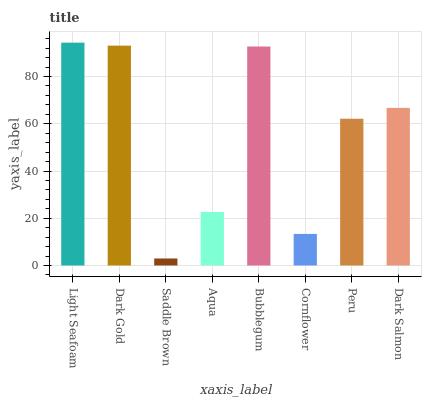Is Saddle Brown the minimum?
Answer yes or no. Yes. Is Light Seafoam the maximum?
Answer yes or no. Yes. Is Dark Gold the minimum?
Answer yes or no. No. Is Dark Gold the maximum?
Answer yes or no. No. Is Light Seafoam greater than Dark Gold?
Answer yes or no. Yes. Is Dark Gold less than Light Seafoam?
Answer yes or no. Yes. Is Dark Gold greater than Light Seafoam?
Answer yes or no. No. Is Light Seafoam less than Dark Gold?
Answer yes or no. No. Is Dark Salmon the high median?
Answer yes or no. Yes. Is Peru the low median?
Answer yes or no. Yes. Is Peru the high median?
Answer yes or no. No. Is Cornflower the low median?
Answer yes or no. No. 